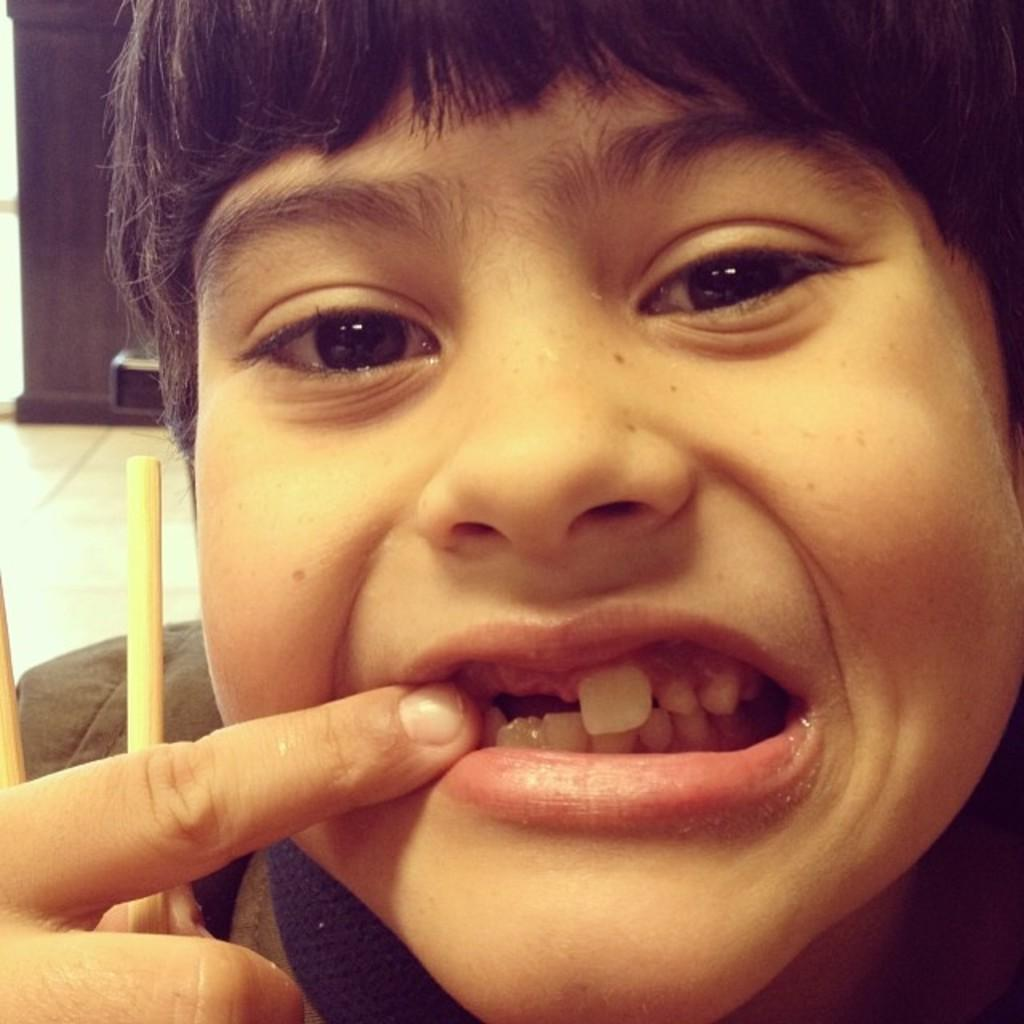What is the main subject of the image? There is a person in the image. What is the person holding in their hands? The person is holding two sticks. How is the person using their finger in the image? The person is holding their teeth with a finger. Can you describe the object in the background of the image? Unfortunately, the provided facts do not give any information about the object in the background. What type of sweater is the person wearing in the image? There is no mention of a sweater in the provided facts, so we cannot determine what type of sweater the person might be wearing. 